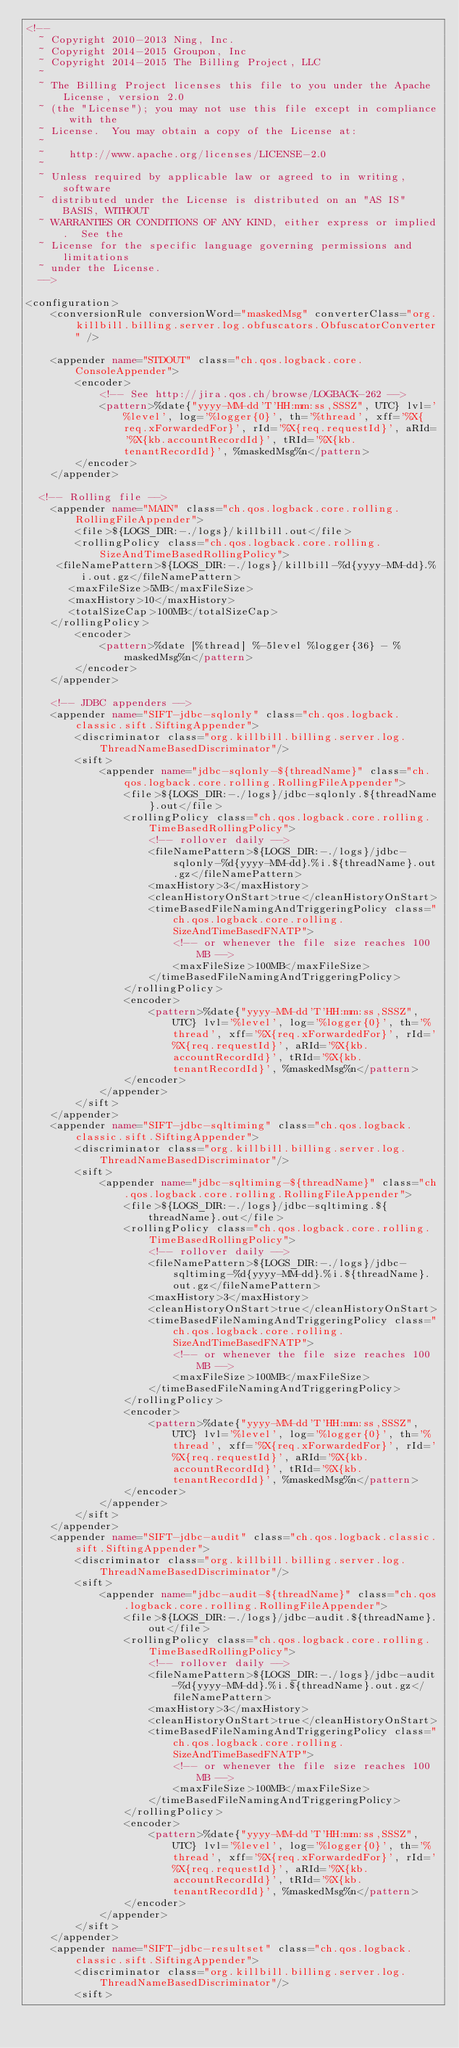Convert code to text. <code><loc_0><loc_0><loc_500><loc_500><_XML_><!--
  ~ Copyright 2010-2013 Ning, Inc.
  ~ Copyright 2014-2015 Groupon, Inc
  ~ Copyright 2014-2015 The Billing Project, LLC
  ~
  ~ The Billing Project licenses this file to you under the Apache License, version 2.0
  ~ (the "License"); you may not use this file except in compliance with the
  ~ License.  You may obtain a copy of the License at:
  ~
  ~    http://www.apache.org/licenses/LICENSE-2.0
  ~
  ~ Unless required by applicable law or agreed to in writing, software
  ~ distributed under the License is distributed on an "AS IS" BASIS, WITHOUT
  ~ WARRANTIES OR CONDITIONS OF ANY KIND, either express or implied.  See the
  ~ License for the specific language governing permissions and limitations
  ~ under the License.
  -->

<configuration>
    <conversionRule conversionWord="maskedMsg" converterClass="org.killbill.billing.server.log.obfuscators.ObfuscatorConverter" />

    <appender name="STDOUT" class="ch.qos.logback.core.ConsoleAppender">
        <encoder>
            <!-- See http://jira.qos.ch/browse/LOGBACK-262 -->
            <pattern>%date{"yyyy-MM-dd'T'HH:mm:ss,SSSZ", UTC} lvl='%level', log='%logger{0}', th='%thread', xff='%X{req.xForwardedFor}', rId='%X{req.requestId}', aRId='%X{kb.accountRecordId}', tRId='%X{kb.tenantRecordId}', %maskedMsg%n</pattern>
        </encoder>
    </appender>

	<!-- Rolling file -->
    <appender name="MAIN" class="ch.qos.logback.core.rolling.RollingFileAppender">
        <file>${LOGS_DIR:-./logs}/killbill.out</file>
        <rollingPolicy class="ch.qos.logback.core.rolling.SizeAndTimeBasedRollingPolicy">
		 <fileNamePattern>${LOGS_DIR:-./logs}/killbill-%d{yyyy-MM-dd}.%i.out.gz</fileNamePattern>
		   <maxFileSize>5MB</maxFileSize>
		   <maxHistory>10</maxHistory>
		   <totalSizeCap>100MB</totalSizeCap>
		</rollingPolicy>
        <encoder>
            <pattern>%date [%thread] %-5level %logger{36} - %maskedMsg%n</pattern>
        </encoder>
    </appender>

    <!-- JDBC appenders -->
    <appender name="SIFT-jdbc-sqlonly" class="ch.qos.logback.classic.sift.SiftingAppender">
        <discriminator class="org.killbill.billing.server.log.ThreadNameBasedDiscriminator"/>
        <sift>
            <appender name="jdbc-sqlonly-${threadName}" class="ch.qos.logback.core.rolling.RollingFileAppender">
                <file>${LOGS_DIR:-./logs}/jdbc-sqlonly.${threadName}.out</file>
                <rollingPolicy class="ch.qos.logback.core.rolling.TimeBasedRollingPolicy">
                    <!-- rollover daily -->
                    <fileNamePattern>${LOGS_DIR:-./logs}/jdbc-sqlonly-%d{yyyy-MM-dd}.%i.${threadName}.out.gz</fileNamePattern>
                    <maxHistory>3</maxHistory>
                    <cleanHistoryOnStart>true</cleanHistoryOnStart>
                    <timeBasedFileNamingAndTriggeringPolicy class="ch.qos.logback.core.rolling.SizeAndTimeBasedFNATP">
                        <!-- or whenever the file size reaches 100MB -->
                        <maxFileSize>100MB</maxFileSize>
                    </timeBasedFileNamingAndTriggeringPolicy>
                </rollingPolicy>
                <encoder>
                    <pattern>%date{"yyyy-MM-dd'T'HH:mm:ss,SSSZ", UTC} lvl='%level', log='%logger{0}', th='%thread', xff='%X{req.xForwardedFor}', rId='%X{req.requestId}', aRId='%X{kb.accountRecordId}', tRId='%X{kb.tenantRecordId}', %maskedMsg%n</pattern>
                </encoder>
            </appender>
        </sift>
    </appender>
    <appender name="SIFT-jdbc-sqltiming" class="ch.qos.logback.classic.sift.SiftingAppender">
        <discriminator class="org.killbill.billing.server.log.ThreadNameBasedDiscriminator"/>
        <sift>
            <appender name="jdbc-sqltiming-${threadName}" class="ch.qos.logback.core.rolling.RollingFileAppender">
                <file>${LOGS_DIR:-./logs}/jdbc-sqltiming.${threadName}.out</file>
                <rollingPolicy class="ch.qos.logback.core.rolling.TimeBasedRollingPolicy">
                    <!-- rollover daily -->
                    <fileNamePattern>${LOGS_DIR:-./logs}/jdbc-sqltiming-%d{yyyy-MM-dd}.%i.${threadName}.out.gz</fileNamePattern>
                    <maxHistory>3</maxHistory>
                    <cleanHistoryOnStart>true</cleanHistoryOnStart>
                    <timeBasedFileNamingAndTriggeringPolicy class="ch.qos.logback.core.rolling.SizeAndTimeBasedFNATP">
                        <!-- or whenever the file size reaches 100MB -->
                        <maxFileSize>100MB</maxFileSize>
                    </timeBasedFileNamingAndTriggeringPolicy>
                </rollingPolicy>
                <encoder>
                    <pattern>%date{"yyyy-MM-dd'T'HH:mm:ss,SSSZ", UTC} lvl='%level', log='%logger{0}', th='%thread', xff='%X{req.xForwardedFor}', rId='%X{req.requestId}', aRId='%X{kb.accountRecordId}', tRId='%X{kb.tenantRecordId}', %maskedMsg%n</pattern>
                </encoder>
            </appender>
        </sift>
    </appender>
    <appender name="SIFT-jdbc-audit" class="ch.qos.logback.classic.sift.SiftingAppender">
        <discriminator class="org.killbill.billing.server.log.ThreadNameBasedDiscriminator"/>
        <sift>
            <appender name="jdbc-audit-${threadName}" class="ch.qos.logback.core.rolling.RollingFileAppender">
                <file>${LOGS_DIR:-./logs}/jdbc-audit.${threadName}.out</file>
                <rollingPolicy class="ch.qos.logback.core.rolling.TimeBasedRollingPolicy">
                    <!-- rollover daily -->
                    <fileNamePattern>${LOGS_DIR:-./logs}/jdbc-audit-%d{yyyy-MM-dd}.%i.${threadName}.out.gz</fileNamePattern>
                    <maxHistory>3</maxHistory>
                    <cleanHistoryOnStart>true</cleanHistoryOnStart>
                    <timeBasedFileNamingAndTriggeringPolicy class="ch.qos.logback.core.rolling.SizeAndTimeBasedFNATP">
                        <!-- or whenever the file size reaches 100MB -->
                        <maxFileSize>100MB</maxFileSize>
                    </timeBasedFileNamingAndTriggeringPolicy>
                </rollingPolicy>
                <encoder>
                    <pattern>%date{"yyyy-MM-dd'T'HH:mm:ss,SSSZ", UTC} lvl='%level', log='%logger{0}', th='%thread', xff='%X{req.xForwardedFor}', rId='%X{req.requestId}', aRId='%X{kb.accountRecordId}', tRId='%X{kb.tenantRecordId}', %maskedMsg%n</pattern>
                </encoder>
            </appender>
        </sift>
    </appender>
    <appender name="SIFT-jdbc-resultset" class="ch.qos.logback.classic.sift.SiftingAppender">
        <discriminator class="org.killbill.billing.server.log.ThreadNameBasedDiscriminator"/>
        <sift></code> 